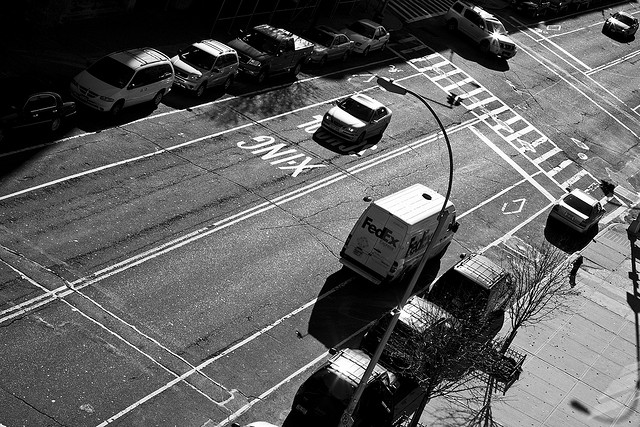Please transcribe the text information in this image. X-ING FedEx FedEx 